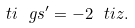Convert formula to latex. <formula><loc_0><loc_0><loc_500><loc_500>\ t i { \ g s } ^ { \prime } = - 2 \ t i { z } .</formula> 